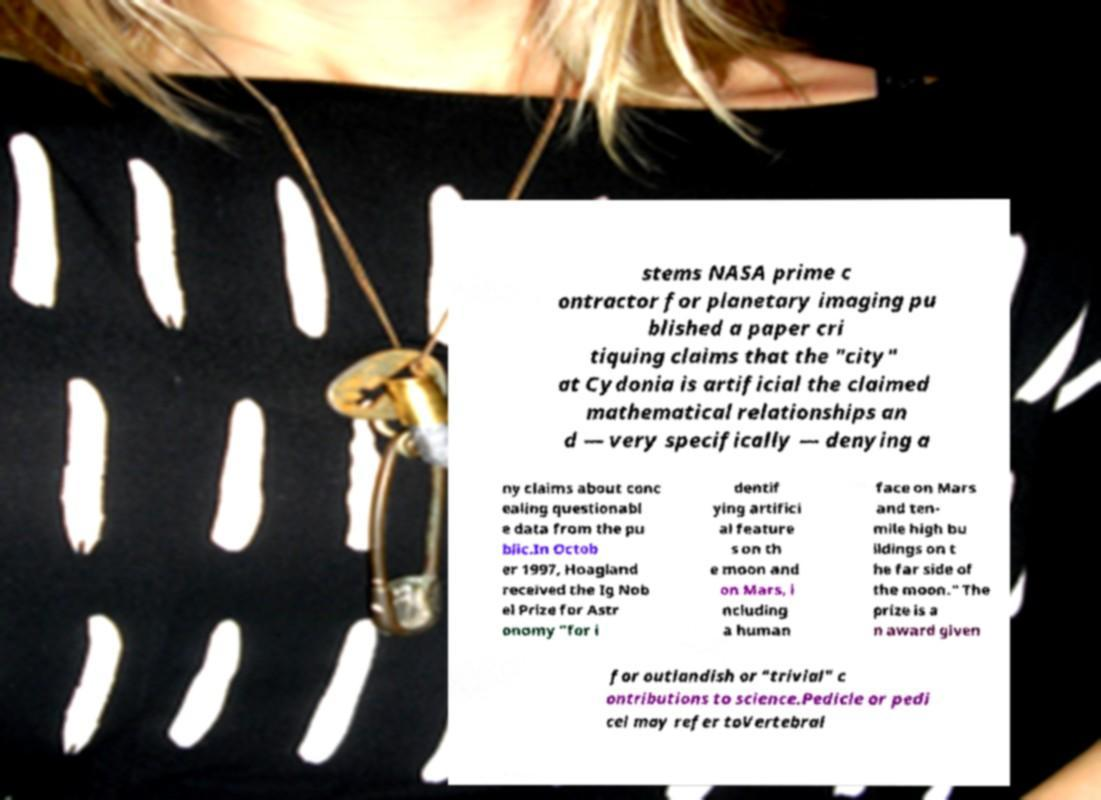There's text embedded in this image that I need extracted. Can you transcribe it verbatim? stems NASA prime c ontractor for planetary imaging pu blished a paper cri tiquing claims that the "city" at Cydonia is artificial the claimed mathematical relationships an d — very specifically — denying a ny claims about conc ealing questionabl e data from the pu blic.In Octob er 1997, Hoagland received the Ig Nob el Prize for Astr onomy "for i dentif ying artifici al feature s on th e moon and on Mars, i ncluding a human face on Mars and ten- mile high bu ildings on t he far side of the moon." The prize is a n award given for outlandish or "trivial" c ontributions to science.Pedicle or pedi cel may refer toVertebral 